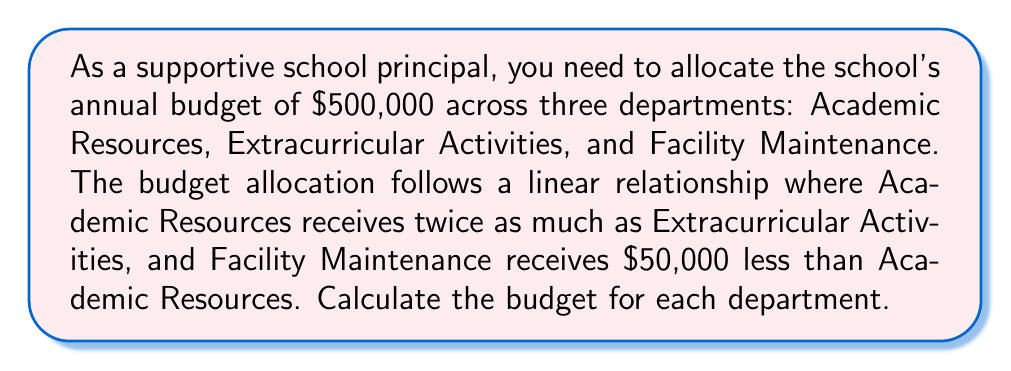Can you solve this math problem? Let's approach this step-by-step:

1) Let x be the budget for Extracurricular Activities.

2) Given the linear relationship:
   Academic Resources = 2x
   Facility Maintenance = 2x - 50,000

3) The total budget equation:
   $x + 2x + (2x - 50,000) = 500,000$

4) Simplify the equation:
   $5x - 50,000 = 500,000$

5) Solve for x:
   $5x = 550,000$
   $x = 110,000$

6) Calculate the budget for each department:
   Extracurricular Activities = $110,000
   Academic Resources = $2(110,000) = $220,000
   Facility Maintenance = $220,000 - $50,000 = $170,000

7) Verify the total:
   $110,000 + $220,000 + $170,000 = $500,000
Answer: Academic Resources: $220,000, Extracurricular Activities: $110,000, Facility Maintenance: $170,000 